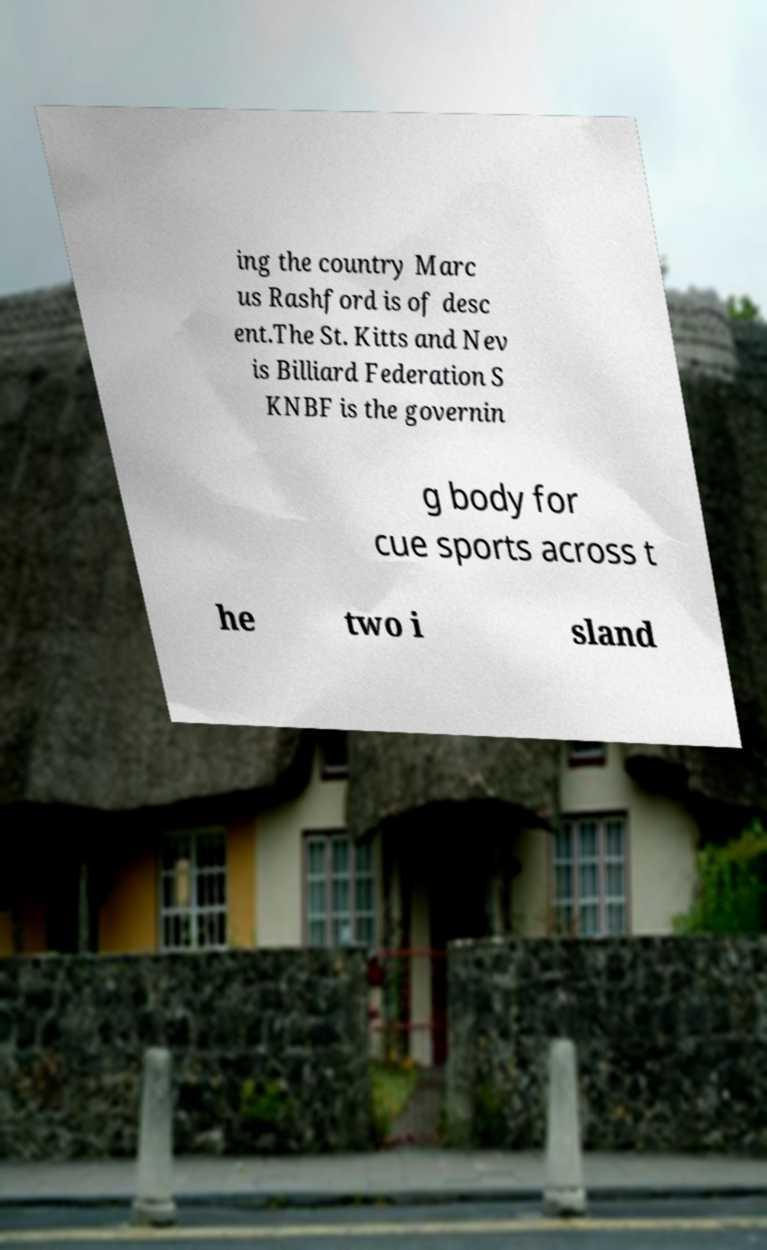Could you assist in decoding the text presented in this image and type it out clearly? ing the country Marc us Rashford is of desc ent.The St. Kitts and Nev is Billiard Federation S KNBF is the governin g body for cue sports across t he two i sland 